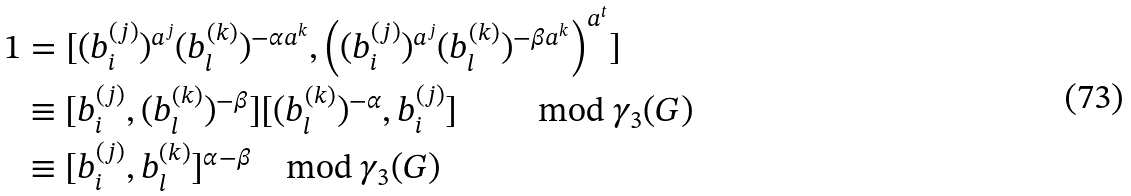Convert formula to latex. <formula><loc_0><loc_0><loc_500><loc_500>1 & = [ ( b ^ { ( j ) } _ { i } ) ^ { a ^ { j } } ( b ^ { ( k ) } _ { l } ) ^ { - \alpha a ^ { k } } , \left ( ( b ^ { ( j ) } _ { i } ) ^ { a ^ { j } } ( b ^ { ( k ) } _ { l } ) ^ { - \beta a ^ { k } } \right ) ^ { a ^ { t } } ] \\ & \equiv [ b ^ { ( j ) } _ { i } , ( b ^ { ( k ) } _ { l } ) ^ { - \beta } ] [ ( b ^ { ( k ) } _ { l } ) ^ { - \alpha } , b ^ { ( j ) } _ { i } ] \quad \, \quad \, \text {mod } \gamma _ { 3 } ( G ) \\ & \equiv [ b ^ { ( j ) } _ { i } , b ^ { ( k ) } _ { l } ] ^ { \alpha - \beta } \quad \text {mod } \gamma _ { 3 } ( G )</formula> 